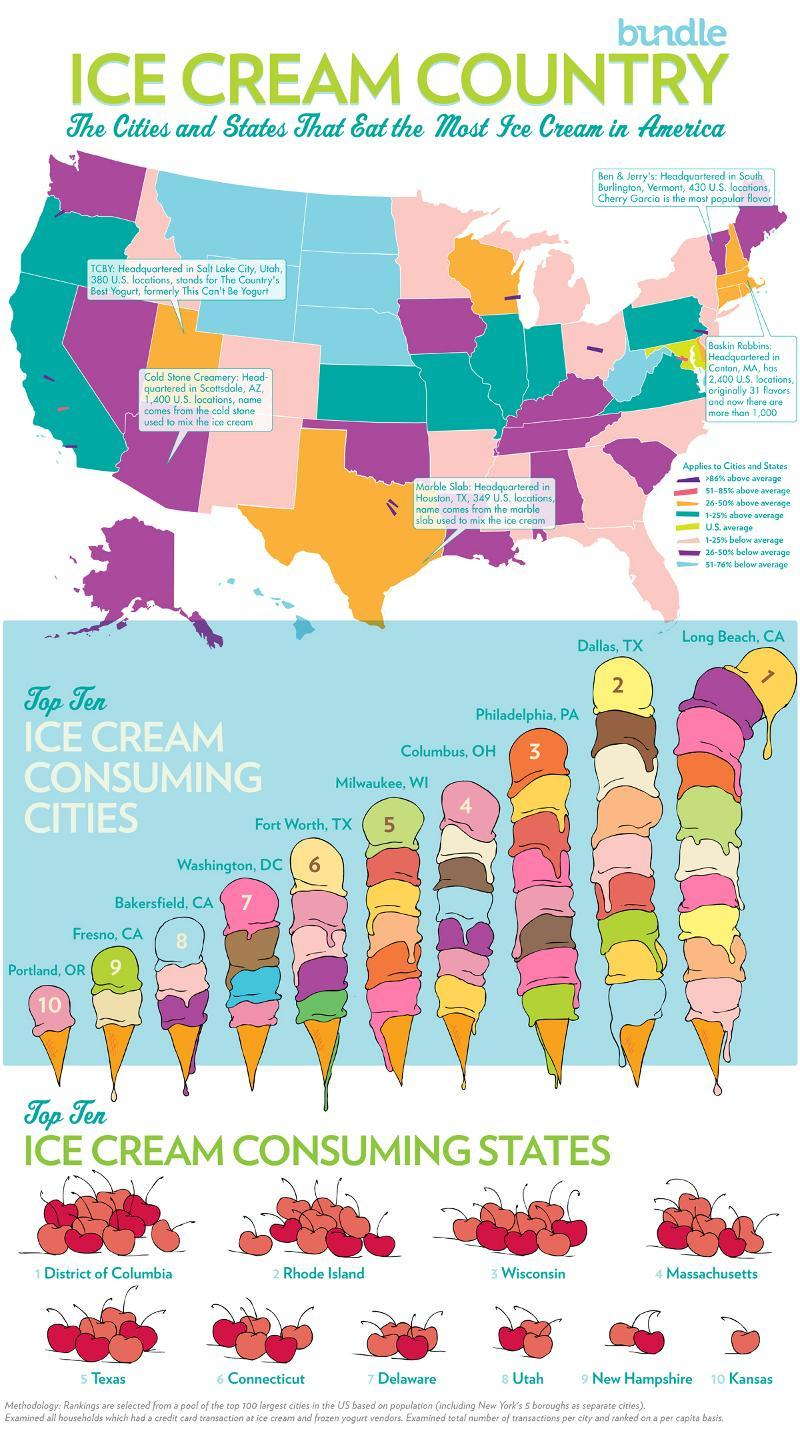Which city consumes ice cream the least?
Answer the question with a short phrase. Portland, OR In which position is Milwaukee, WI in terms of ice cream consumption? 5 Which state consumes ice cream the most? District of Columbia 